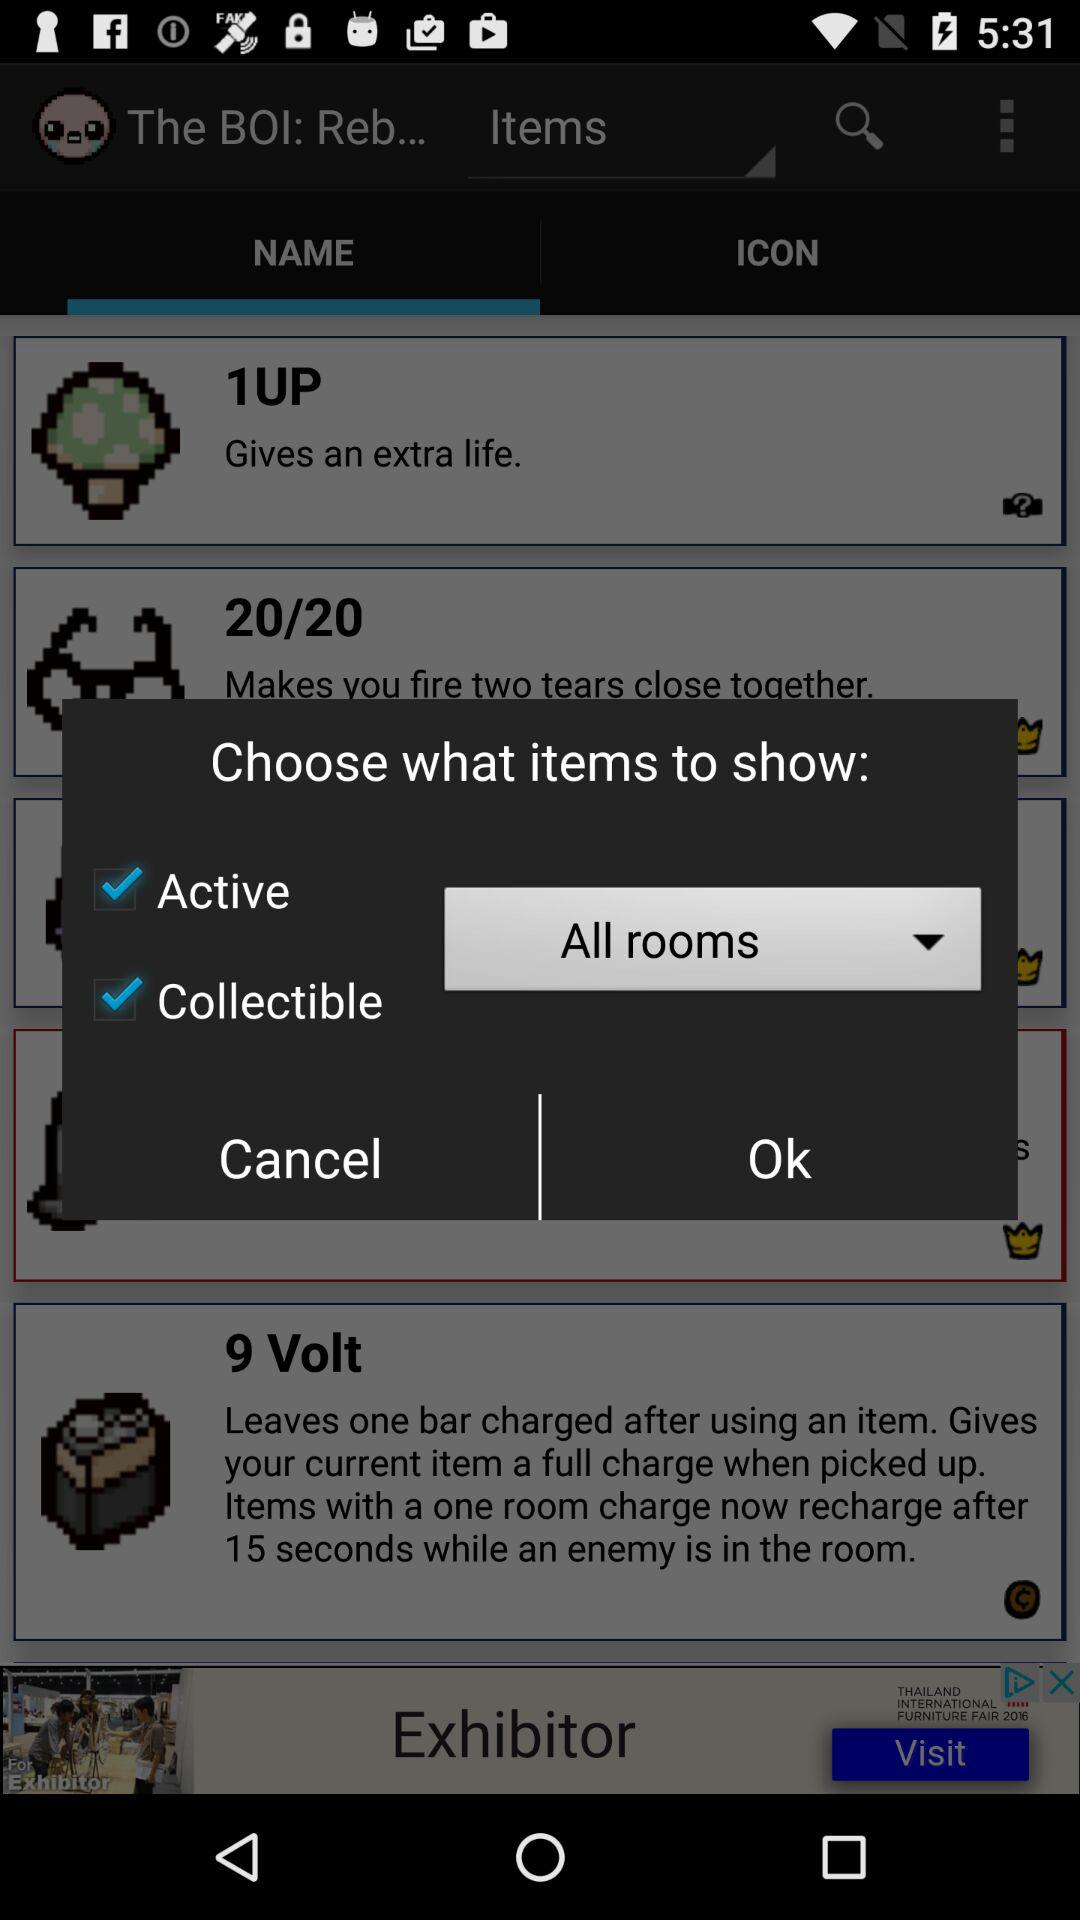What is the status of collectible? The status is on. 